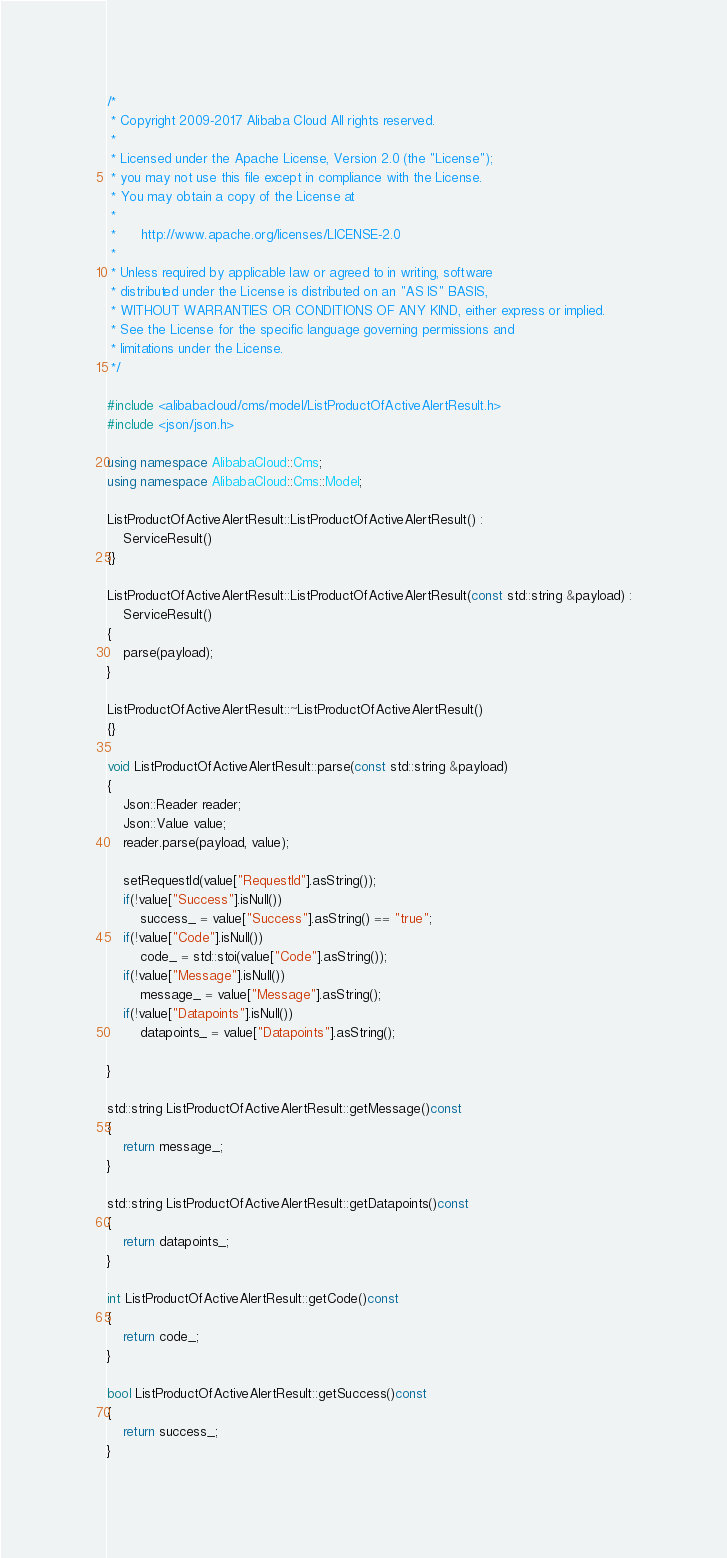<code> <loc_0><loc_0><loc_500><loc_500><_C++_>/*
 * Copyright 2009-2017 Alibaba Cloud All rights reserved.
 * 
 * Licensed under the Apache License, Version 2.0 (the "License");
 * you may not use this file except in compliance with the License.
 * You may obtain a copy of the License at
 * 
 *      http://www.apache.org/licenses/LICENSE-2.0
 * 
 * Unless required by applicable law or agreed to in writing, software
 * distributed under the License is distributed on an "AS IS" BASIS,
 * WITHOUT WARRANTIES OR CONDITIONS OF ANY KIND, either express or implied.
 * See the License for the specific language governing permissions and
 * limitations under the License.
 */

#include <alibabacloud/cms/model/ListProductOfActiveAlertResult.h>
#include <json/json.h>

using namespace AlibabaCloud::Cms;
using namespace AlibabaCloud::Cms::Model;

ListProductOfActiveAlertResult::ListProductOfActiveAlertResult() :
	ServiceResult()
{}

ListProductOfActiveAlertResult::ListProductOfActiveAlertResult(const std::string &payload) :
	ServiceResult()
{
	parse(payload);
}

ListProductOfActiveAlertResult::~ListProductOfActiveAlertResult()
{}

void ListProductOfActiveAlertResult::parse(const std::string &payload)
{
	Json::Reader reader;
	Json::Value value;
	reader.parse(payload, value);

	setRequestId(value["RequestId"].asString());
	if(!value["Success"].isNull())
		success_ = value["Success"].asString() == "true";
	if(!value["Code"].isNull())
		code_ = std::stoi(value["Code"].asString());
	if(!value["Message"].isNull())
		message_ = value["Message"].asString();
	if(!value["Datapoints"].isNull())
		datapoints_ = value["Datapoints"].asString();

}

std::string ListProductOfActiveAlertResult::getMessage()const
{
	return message_;
}

std::string ListProductOfActiveAlertResult::getDatapoints()const
{
	return datapoints_;
}

int ListProductOfActiveAlertResult::getCode()const
{
	return code_;
}

bool ListProductOfActiveAlertResult::getSuccess()const
{
	return success_;
}

</code> 